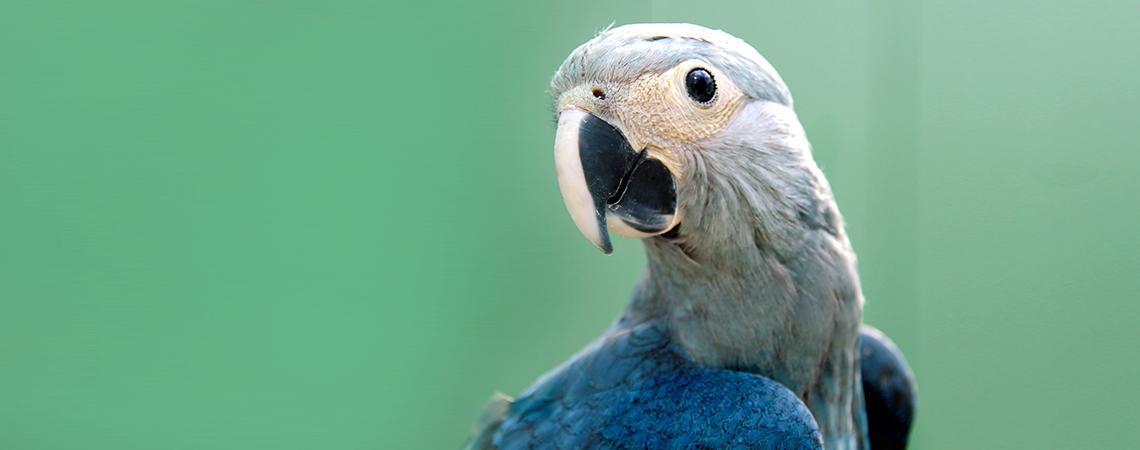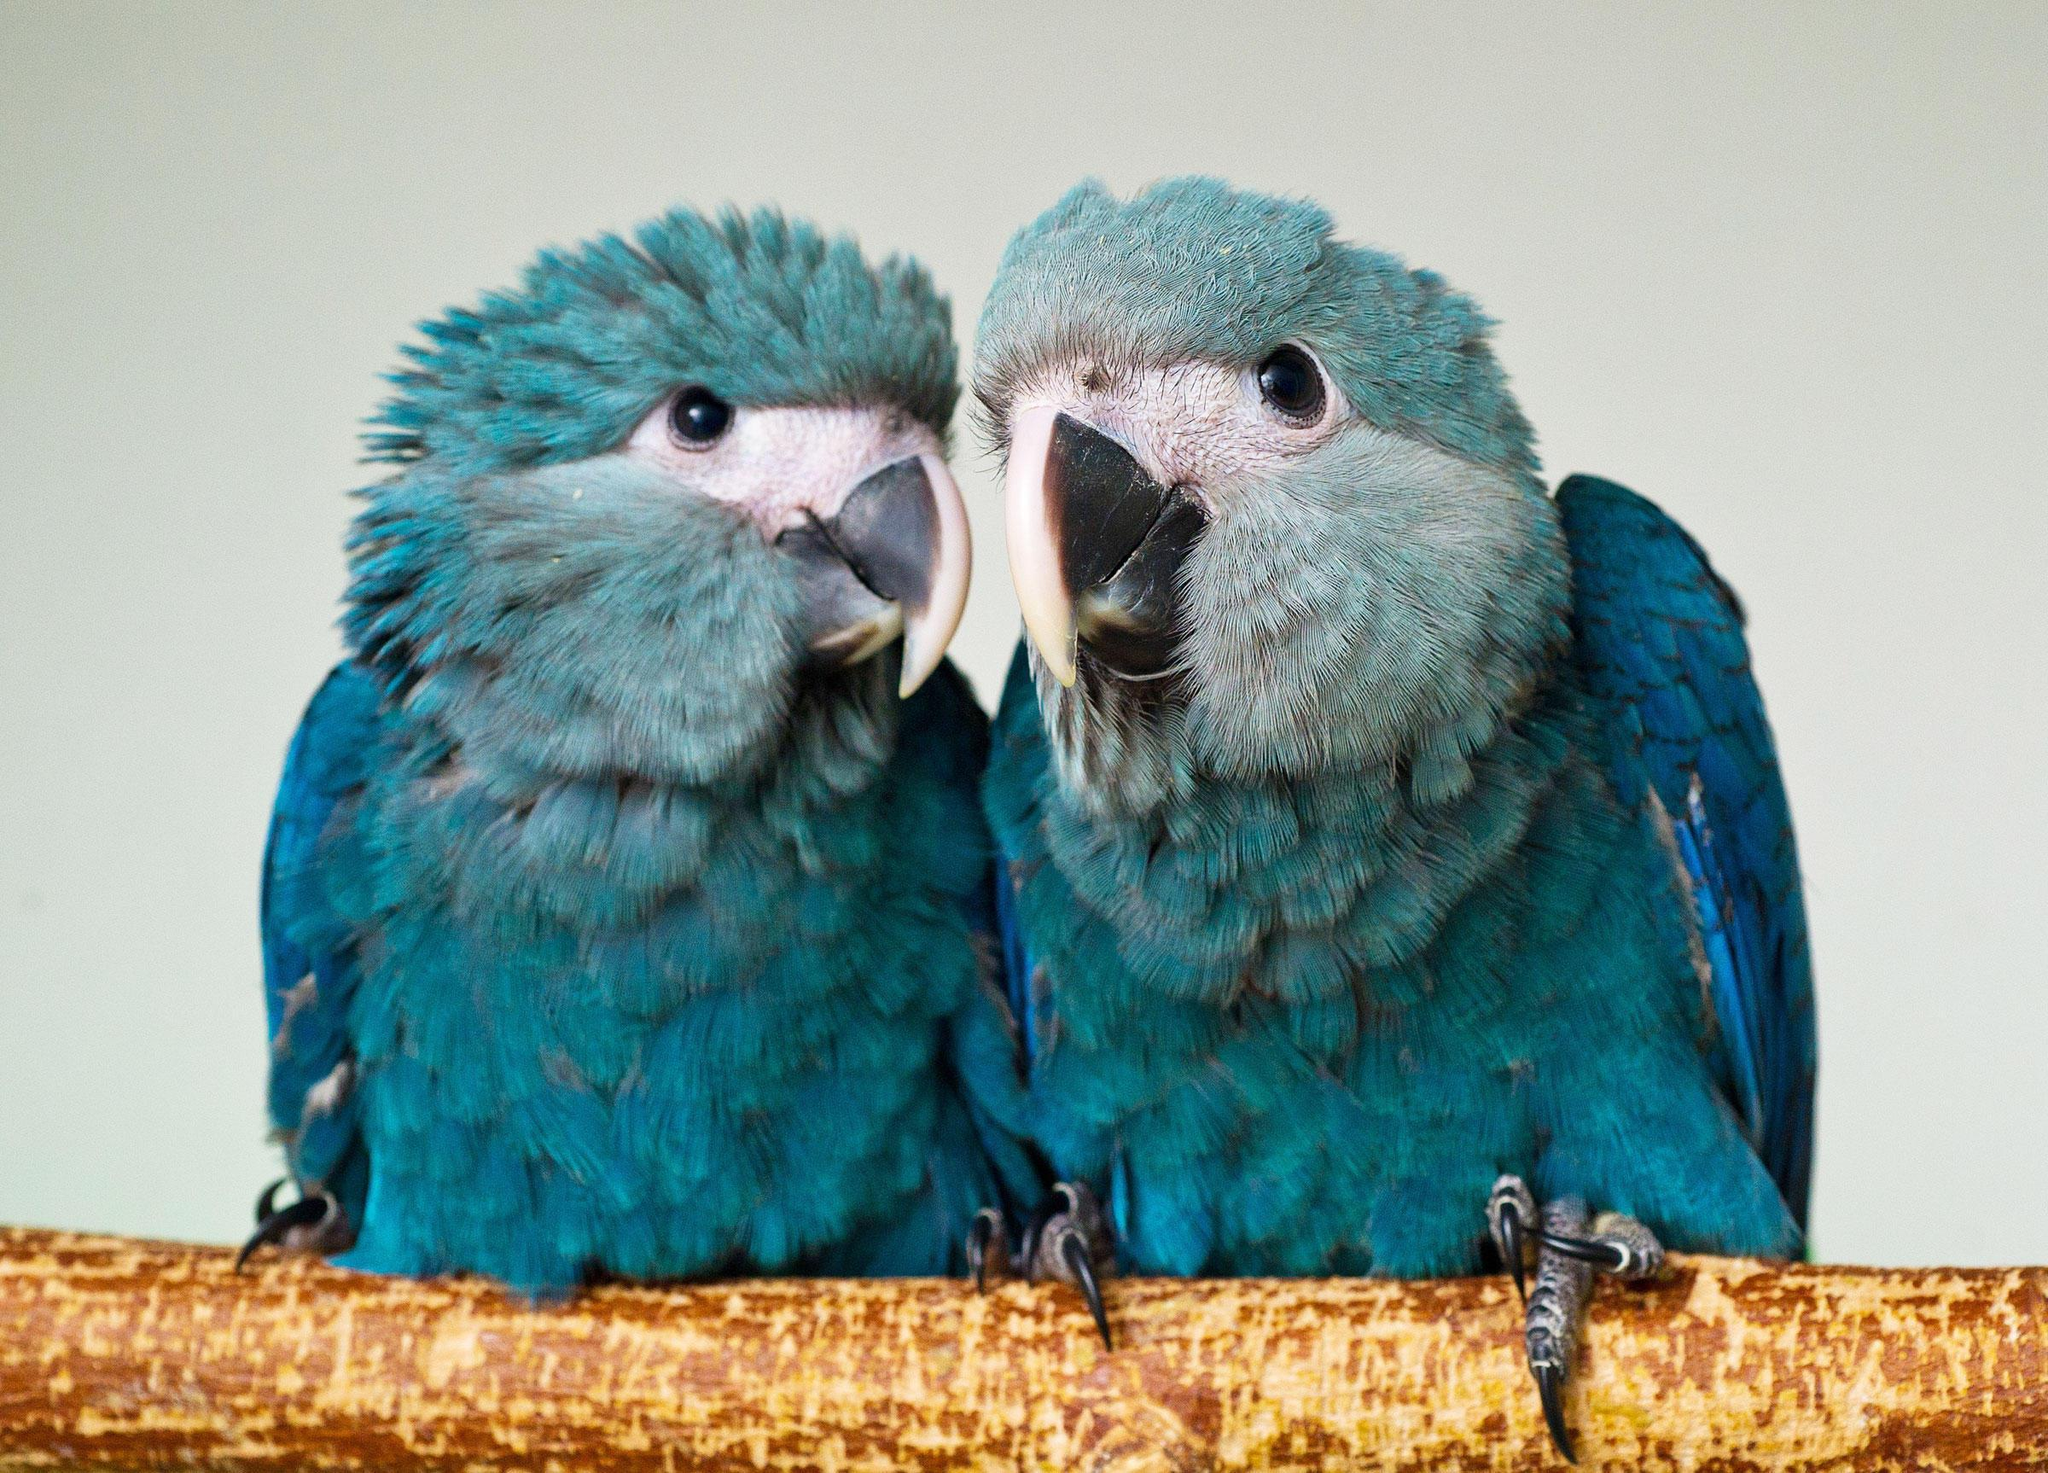The first image is the image on the left, the second image is the image on the right. For the images displayed, is the sentence "There are two birds in the left image and one bird in the right image." factually correct? Answer yes or no. No. The first image is the image on the left, the second image is the image on the right. Given the left and right images, does the statement "All blue parrots have white faces with black eyes and beak that is black and white." hold true? Answer yes or no. Yes. 